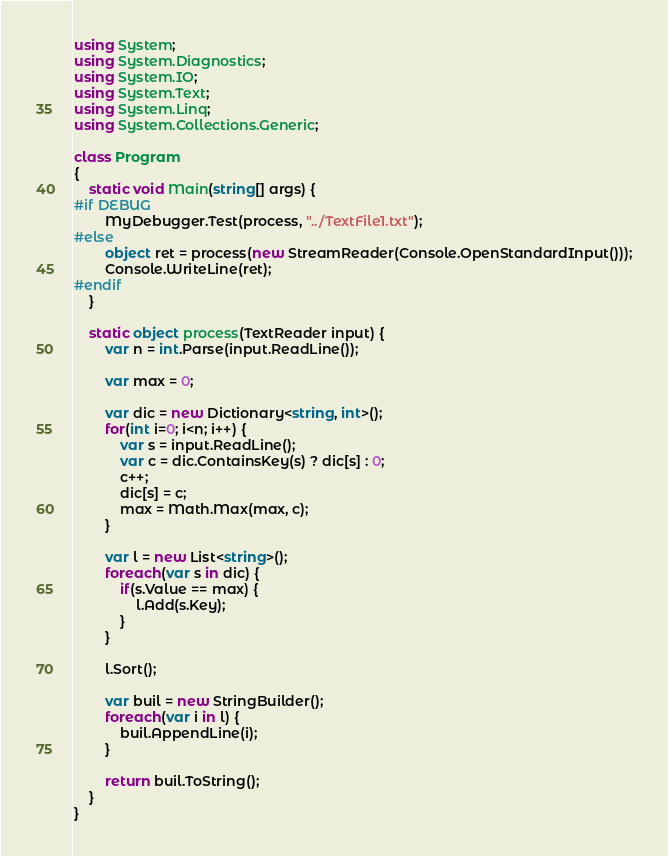Convert code to text. <code><loc_0><loc_0><loc_500><loc_500><_C#_>using System;
using System.Diagnostics;
using System.IO;
using System.Text;
using System.Linq;
using System.Collections.Generic;

class Program
{
    static void Main(string[] args) {
#if DEBUG
        MyDebugger.Test(process, "../TextFile1.txt");
#else
        object ret = process(new StreamReader(Console.OpenStandardInput()));
        Console.WriteLine(ret);
#endif
    }

    static object process(TextReader input) {
        var n = int.Parse(input.ReadLine());

        var max = 0;

        var dic = new Dictionary<string, int>();
        for(int i=0; i<n; i++) {
            var s = input.ReadLine();
            var c = dic.ContainsKey(s) ? dic[s] : 0;
            c++;
            dic[s] = c;
            max = Math.Max(max, c);
        }

        var l = new List<string>();
        foreach(var s in dic) {
            if(s.Value == max) {
                l.Add(s.Key);
            }
        }

        l.Sort();

        var buil = new StringBuilder();
        foreach(var i in l) {
            buil.AppendLine(i);
        }

        return buil.ToString();
    }
}
</code> 